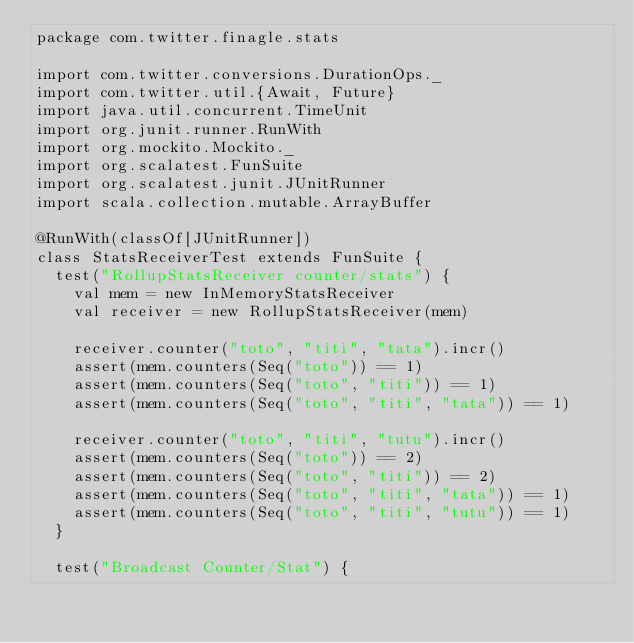Convert code to text. <code><loc_0><loc_0><loc_500><loc_500><_Scala_>package com.twitter.finagle.stats

import com.twitter.conversions.DurationOps._
import com.twitter.util.{Await, Future}
import java.util.concurrent.TimeUnit
import org.junit.runner.RunWith
import org.mockito.Mockito._
import org.scalatest.FunSuite
import org.scalatest.junit.JUnitRunner
import scala.collection.mutable.ArrayBuffer

@RunWith(classOf[JUnitRunner])
class StatsReceiverTest extends FunSuite {
  test("RollupStatsReceiver counter/stats") {
    val mem = new InMemoryStatsReceiver
    val receiver = new RollupStatsReceiver(mem)

    receiver.counter("toto", "titi", "tata").incr()
    assert(mem.counters(Seq("toto")) == 1)
    assert(mem.counters(Seq("toto", "titi")) == 1)
    assert(mem.counters(Seq("toto", "titi", "tata")) == 1)

    receiver.counter("toto", "titi", "tutu").incr()
    assert(mem.counters(Seq("toto")) == 2)
    assert(mem.counters(Seq("toto", "titi")) == 2)
    assert(mem.counters(Seq("toto", "titi", "tata")) == 1)
    assert(mem.counters(Seq("toto", "titi", "tutu")) == 1)
  }

  test("Broadcast Counter/Stat") {</code> 